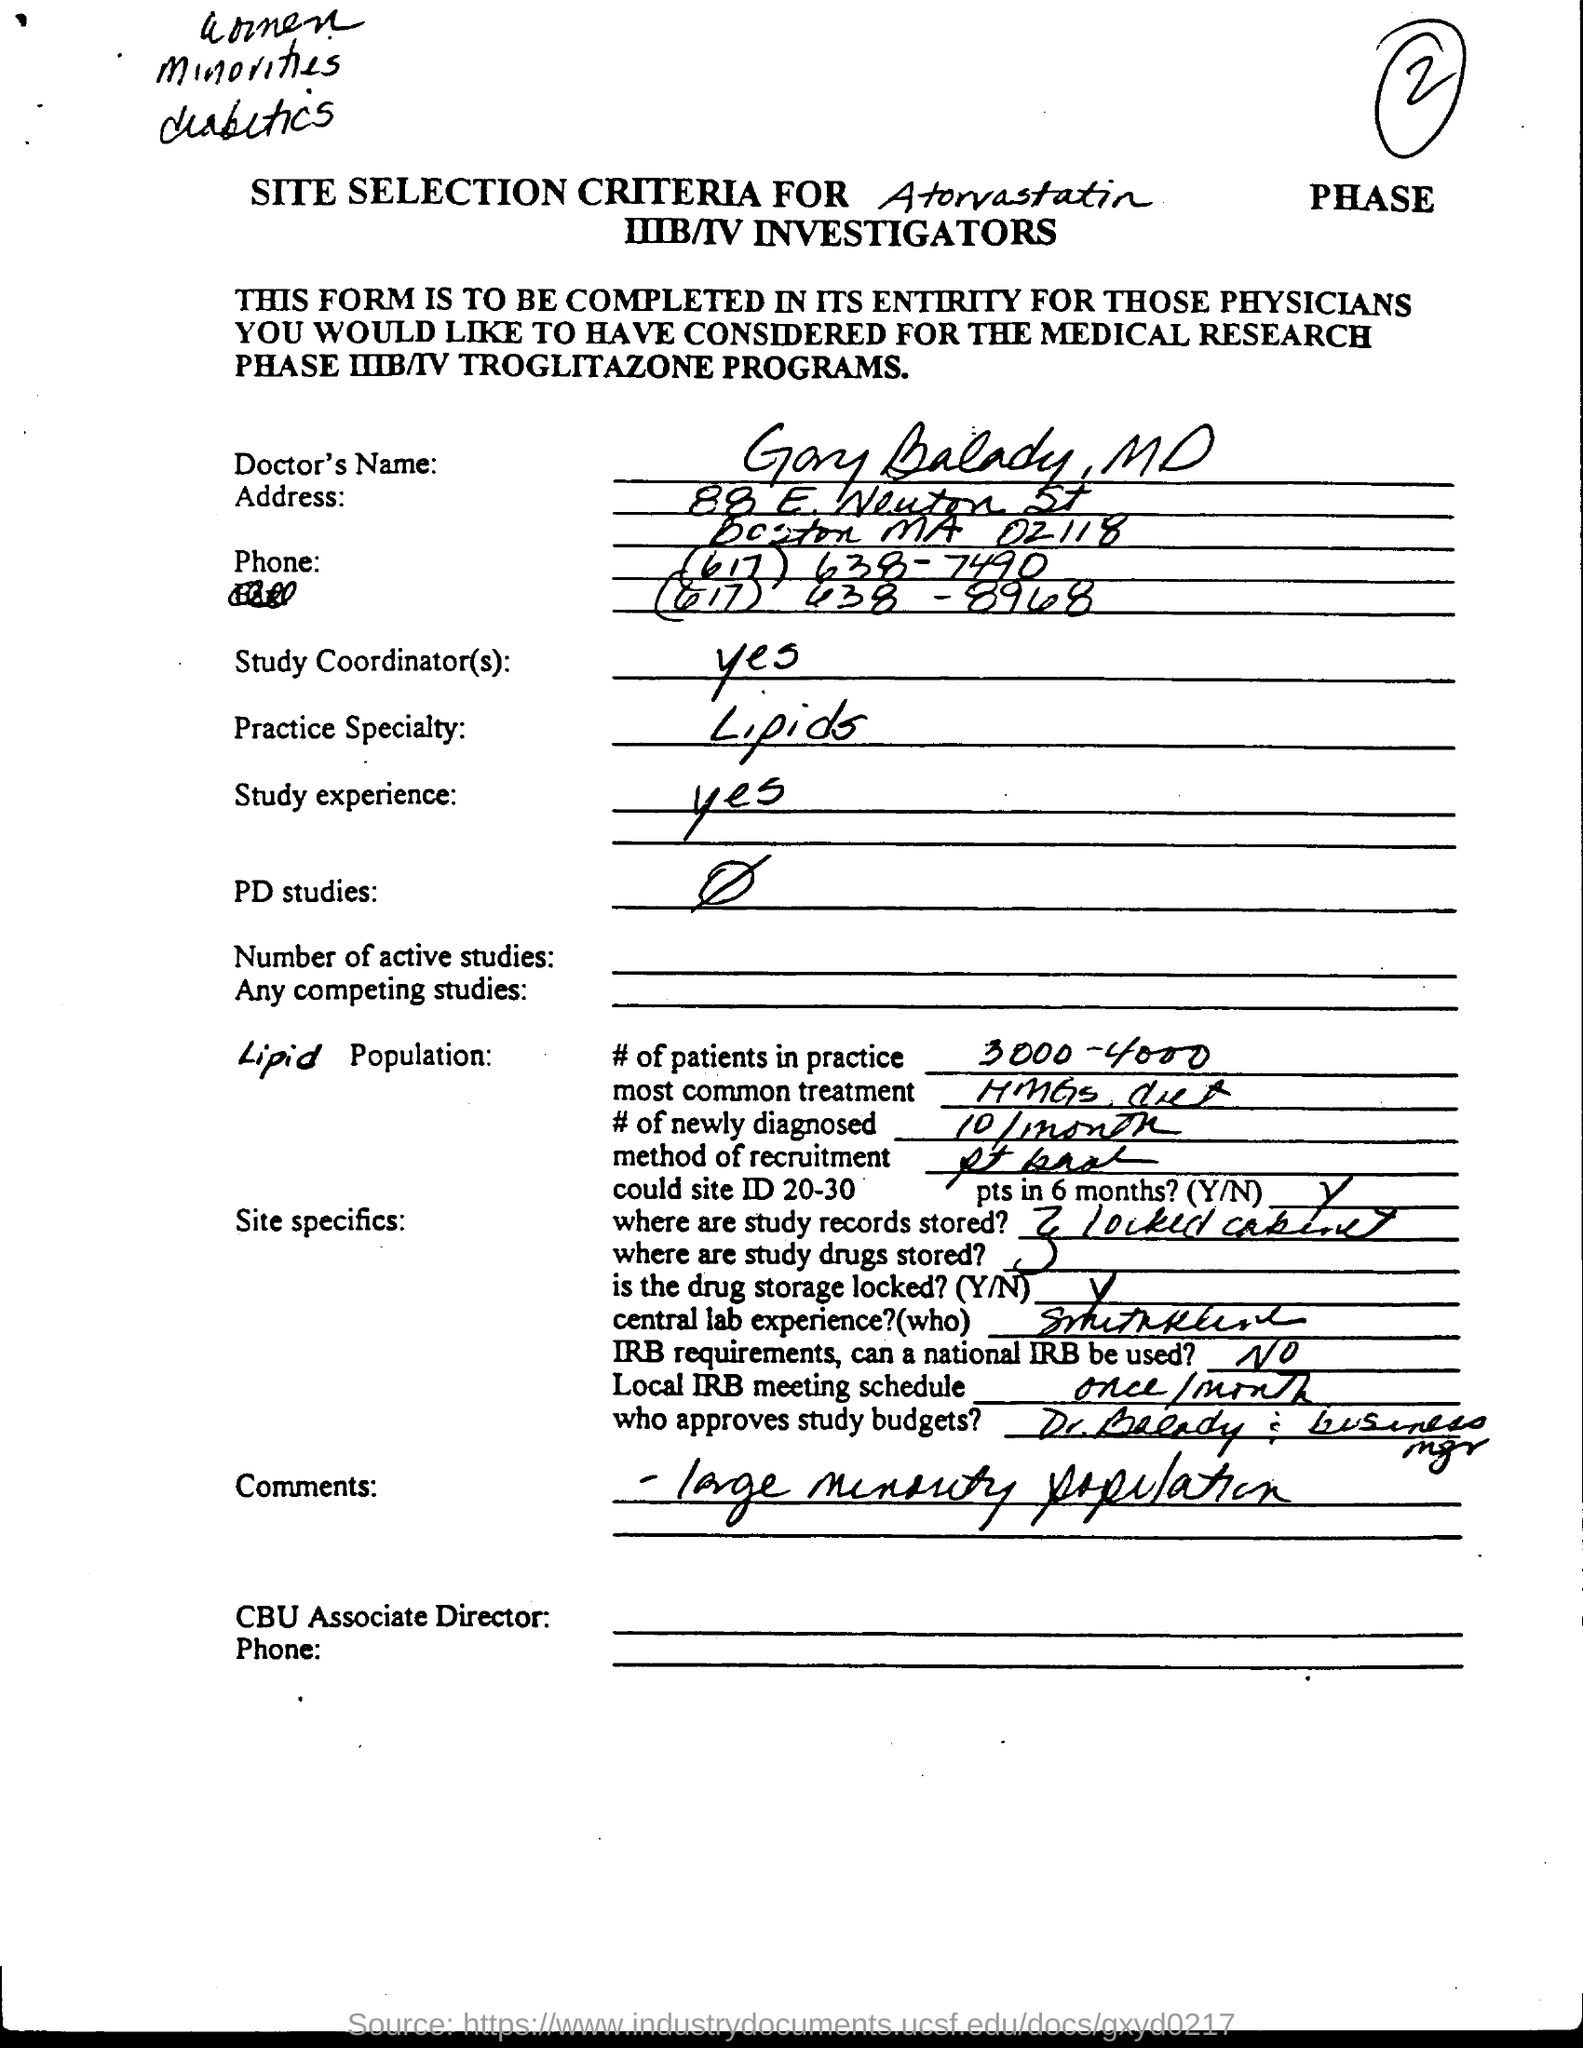What is the practice speciality?
Make the answer very short. Lipids. What is the number of newly diagonised?
Make the answer very short. 10/month. Where are the study records and study drugs stored?
Provide a short and direct response. Locked cabinet. When is the local irb meeting scheduled?
Make the answer very short. Once/month. 